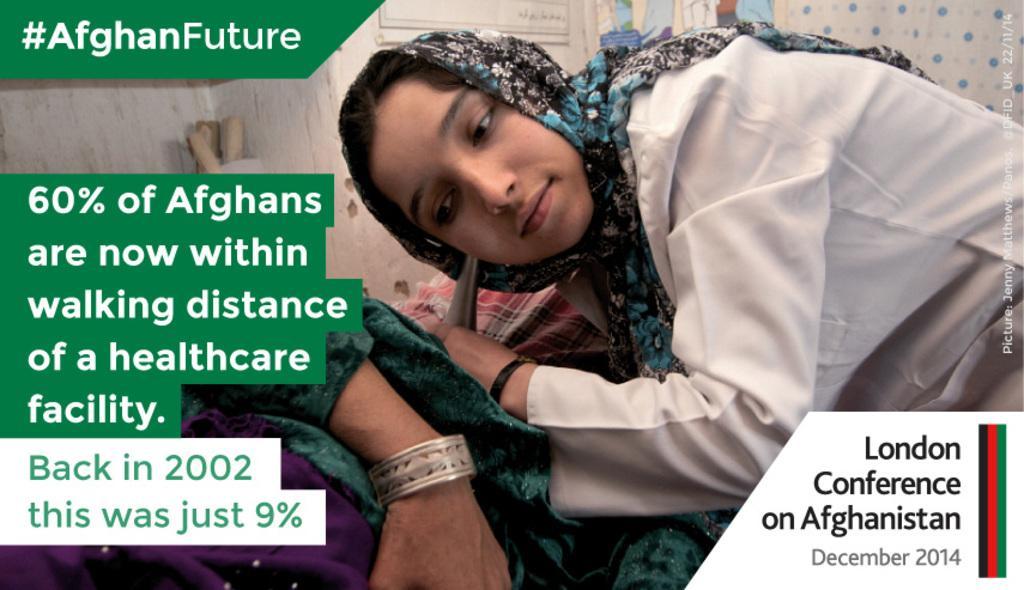Describe this image in one or two sentences. In this image there are people, posters and objects. Posters are on the wall. A woman is holding an object. Something is written on the image. On the right side of the image there is a watermark.   